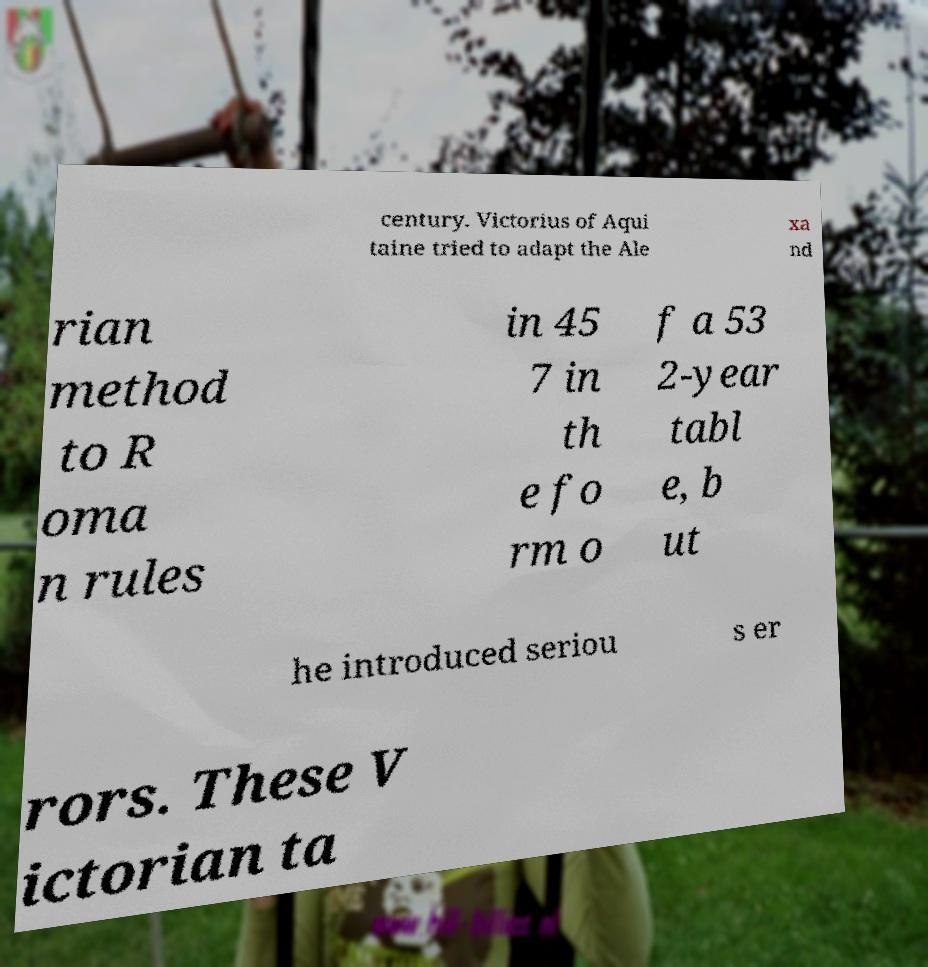What messages or text are displayed in this image? I need them in a readable, typed format. century. Victorius of Aqui taine tried to adapt the Ale xa nd rian method to R oma n rules in 45 7 in th e fo rm o f a 53 2-year tabl e, b ut he introduced seriou s er rors. These V ictorian ta 